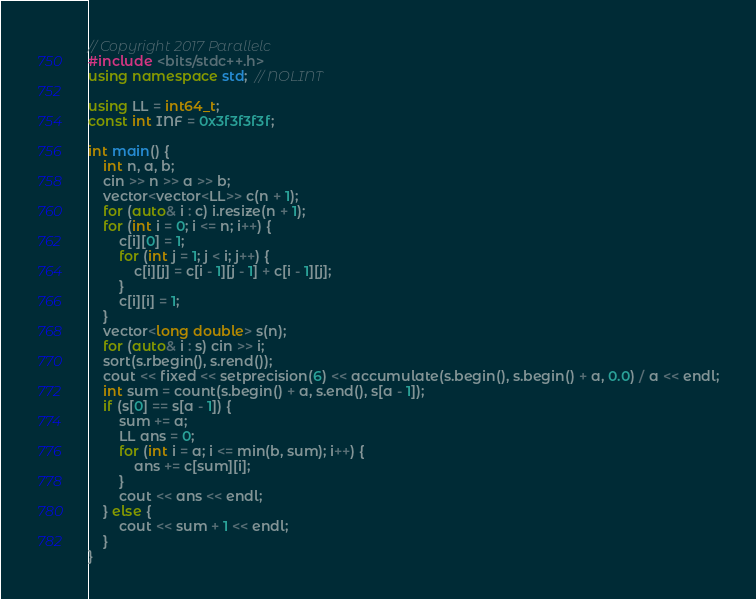<code> <loc_0><loc_0><loc_500><loc_500><_C++_>// Copyright 2017 Parallelc
#include <bits/stdc++.h>
using namespace std;  // NOLINT

using LL = int64_t;
const int INF = 0x3f3f3f3f;

int main() {
    int n, a, b;
    cin >> n >> a >> b;
    vector<vector<LL>> c(n + 1);
    for (auto& i : c) i.resize(n + 1);
    for (int i = 0; i <= n; i++) {
        c[i][0] = 1;
        for (int j = 1; j < i; j++) {
            c[i][j] = c[i - 1][j - 1] + c[i - 1][j];
        }
        c[i][i] = 1;
    }
    vector<long double> s(n);
    for (auto& i : s) cin >> i;
    sort(s.rbegin(), s.rend());
    cout << fixed << setprecision(6) << accumulate(s.begin(), s.begin() + a, 0.0) / a << endl;
    int sum = count(s.begin() + a, s.end(), s[a - 1]);
    if (s[0] == s[a - 1]) {
        sum += a;
        LL ans = 0;
        for (int i = a; i <= min(b, sum); i++) {
            ans += c[sum][i];
        }
        cout << ans << endl;
    } else {
        cout << sum + 1 << endl;
    }
}</code> 